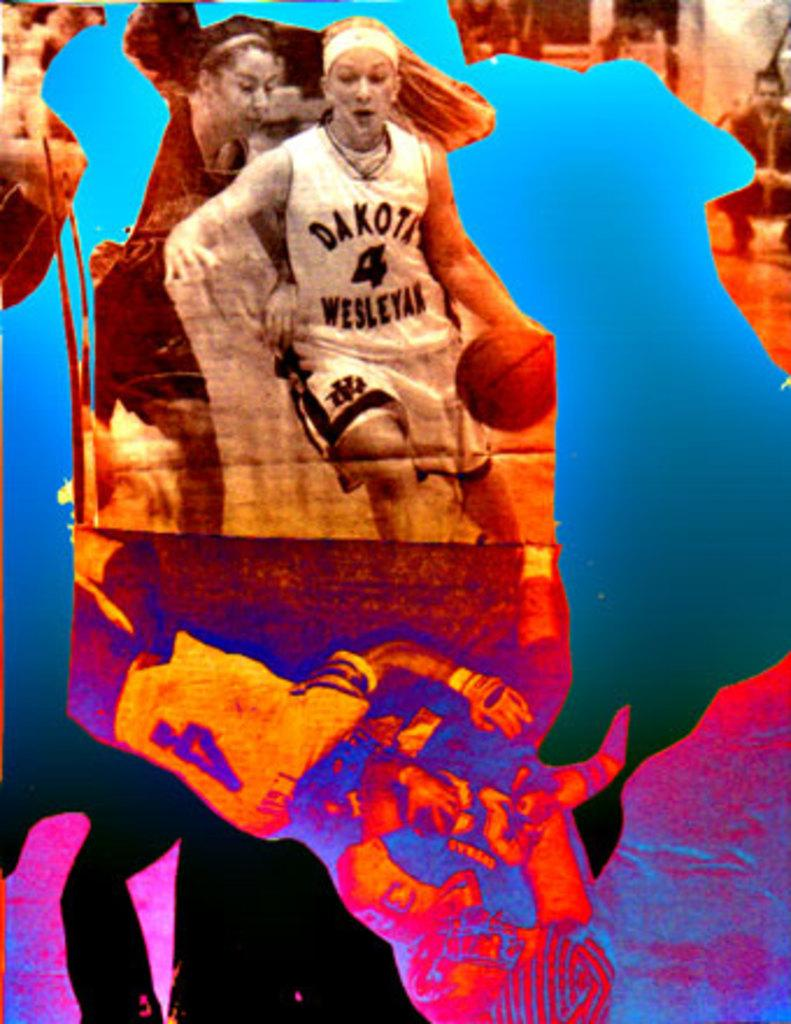What is the main subject of the image? There is a person in the image. What is the person holding in the image? The person is holding a basketball. Where is the person and the basketball located in the image? The person and the basketball are in the center of the image. What type of nest can be seen in the image? There is no nest present in the image; it features a person holding a basketball. 